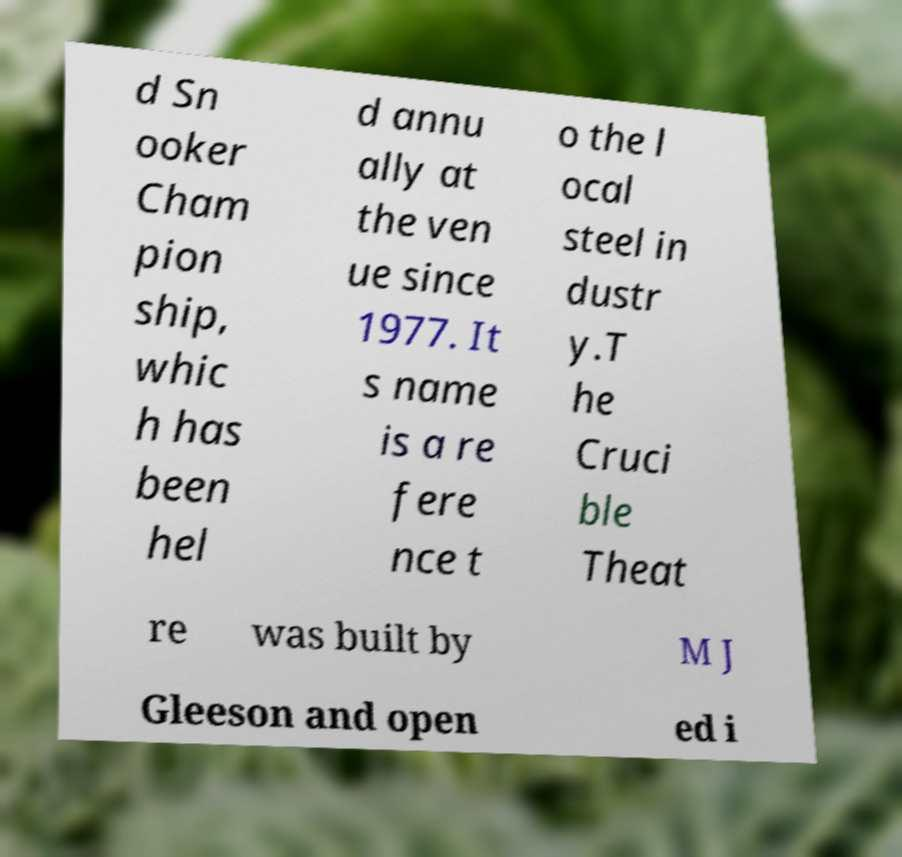Can you accurately transcribe the text from the provided image for me? d Sn ooker Cham pion ship, whic h has been hel d annu ally at the ven ue since 1977. It s name is a re fere nce t o the l ocal steel in dustr y.T he Cruci ble Theat re was built by M J Gleeson and open ed i 